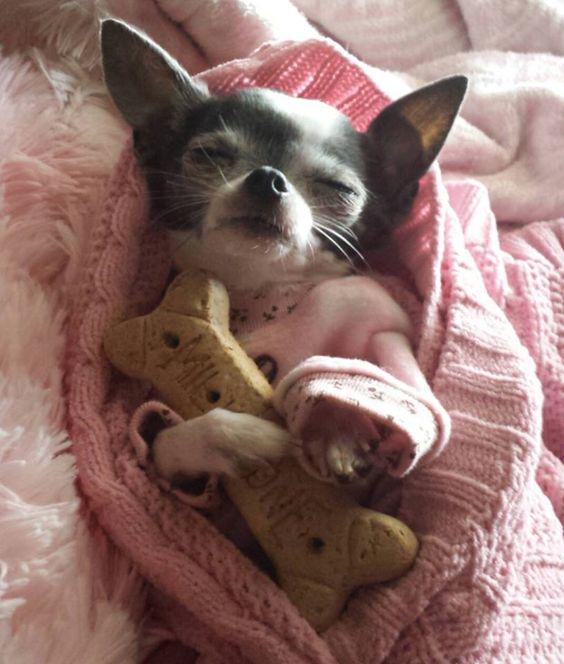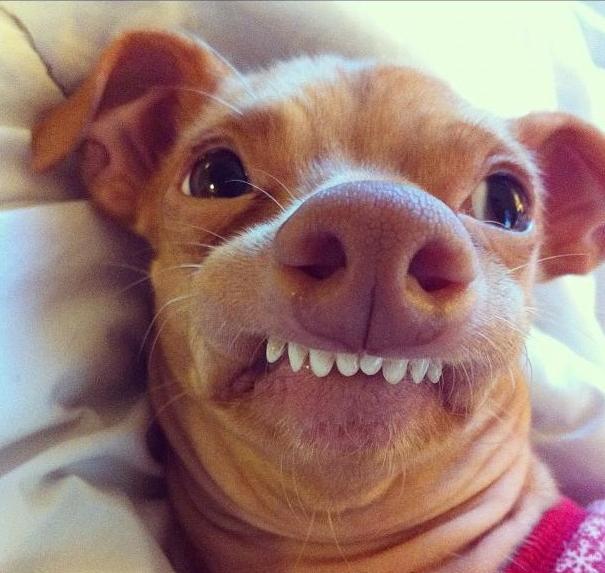The first image is the image on the left, the second image is the image on the right. Assess this claim about the two images: "In the left image, a dog is cuddling another object.". Correct or not? Answer yes or no. Yes. The first image is the image on the left, the second image is the image on the right. Examine the images to the left and right. Is the description "A puppy with dark and light fur is sleeping with a dimensional object between its paws." accurate? Answer yes or no. Yes. 